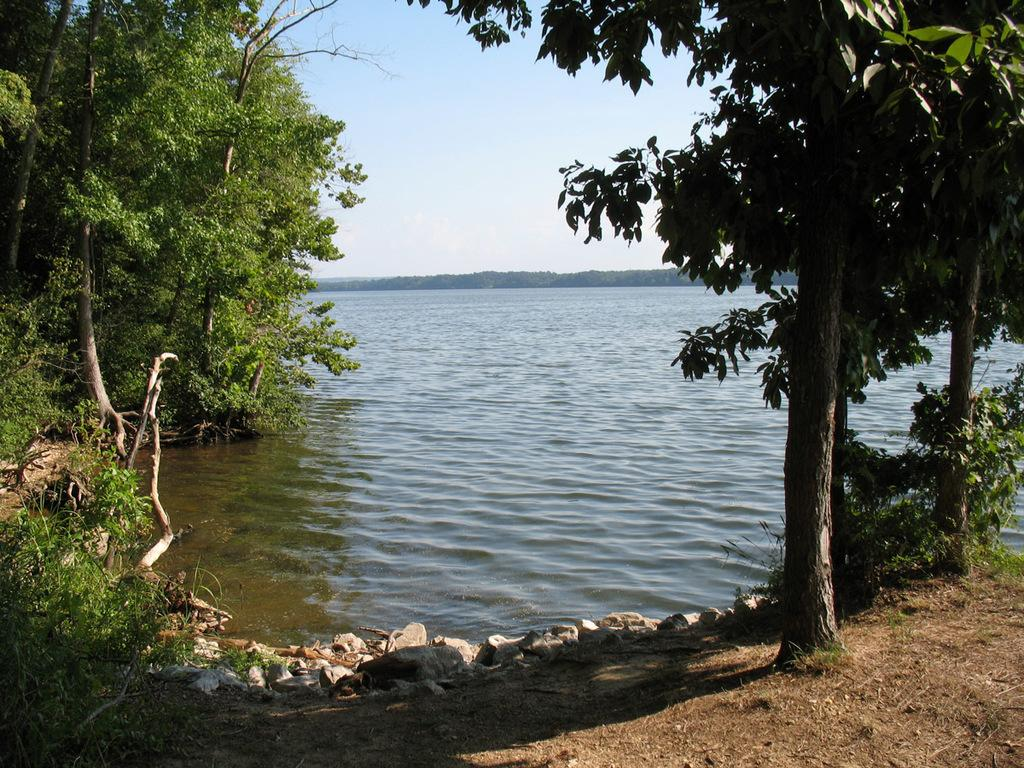What type of natural feature is present in the image? There is a river in the image. What can be found on the bank of the river? There are stones on the bank of the river. What other natural elements are visible in the image? There are trees in the image. What is visible in the background of the image? The sky is visible in the background of the image. What type of destruction can be seen on the river in the image? There is no destruction present in the image. The image features a river, stones on the bank, trees, and a visible sky in the background. 